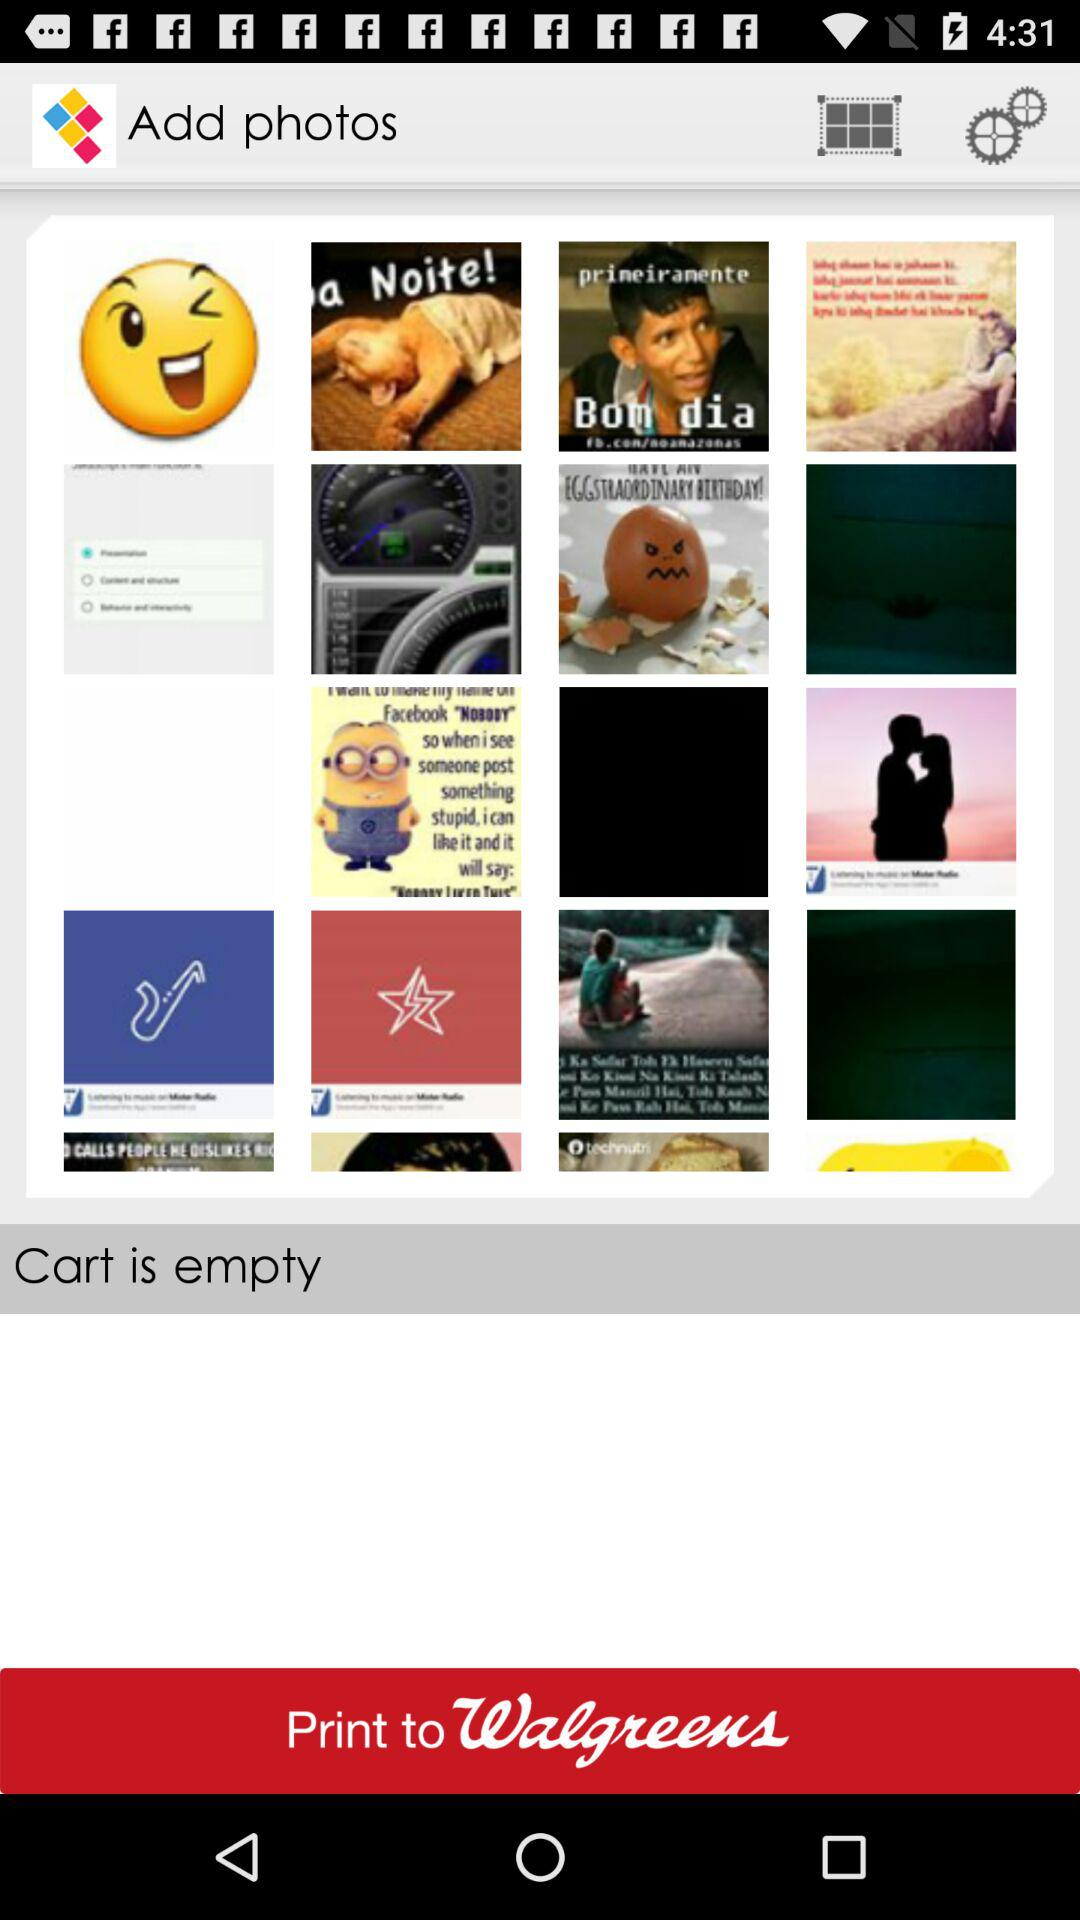Is there any item in the cart? The cart is empty. 